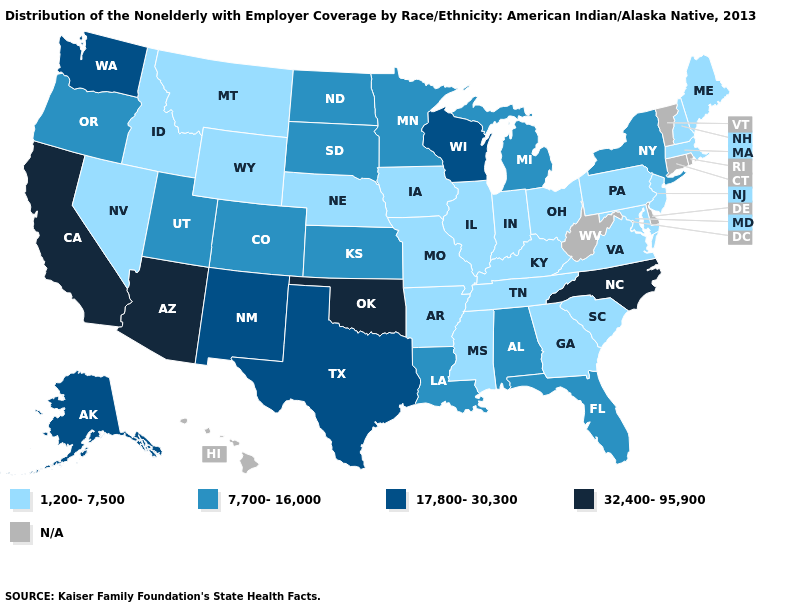Does the map have missing data?
Answer briefly. Yes. How many symbols are there in the legend?
Keep it brief. 5. Does Pennsylvania have the lowest value in the Northeast?
Short answer required. Yes. What is the value of Florida?
Concise answer only. 7,700-16,000. Is the legend a continuous bar?
Be succinct. No. What is the highest value in the USA?
Short answer required. 32,400-95,900. Which states have the highest value in the USA?
Write a very short answer. Arizona, California, North Carolina, Oklahoma. Which states hav the highest value in the South?
Quick response, please. North Carolina, Oklahoma. What is the value of Delaware?
Answer briefly. N/A. Does the map have missing data?
Keep it brief. Yes. What is the value of Wisconsin?
Write a very short answer. 17,800-30,300. What is the lowest value in the South?
Concise answer only. 1,200-7,500. Which states hav the highest value in the West?
Concise answer only. Arizona, California. Does Colorado have the highest value in the USA?
Short answer required. No. 